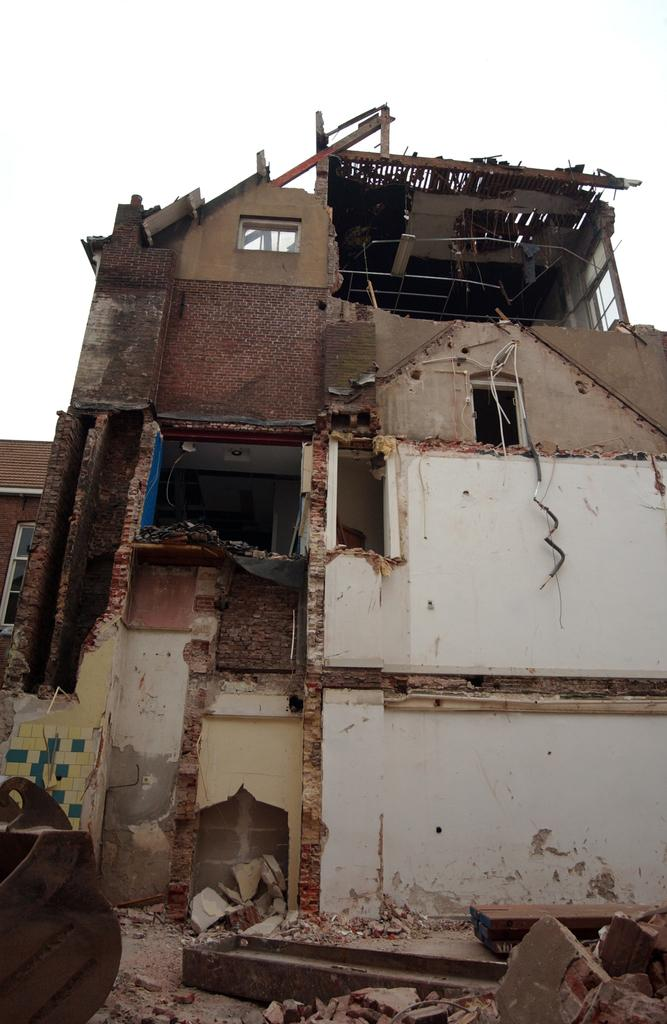What type of structure is visible in the image? There is a building in the image. What is the condition of the building in the image? The building appears to be collapsed. What is visible at the top of the image? The sky is visible at the top of the image. How does the building show respect to its neighbors in the image? The building does not show respect to its neighbors in the image, as it is collapsed and not functioning as a structure. 